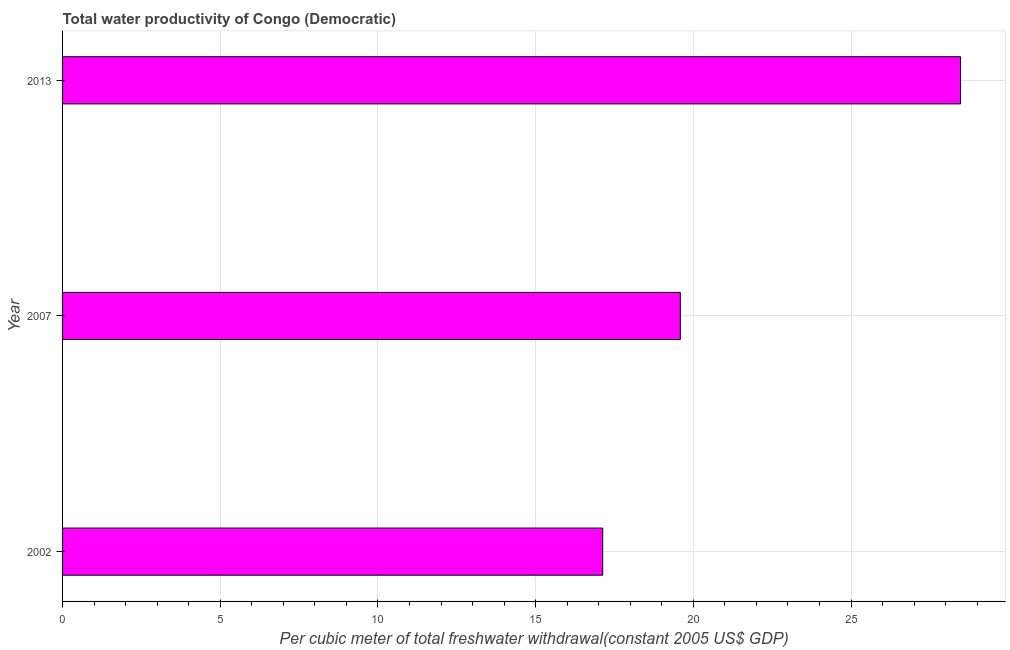Does the graph contain any zero values?
Provide a short and direct response. No. Does the graph contain grids?
Provide a succinct answer. Yes. What is the title of the graph?
Make the answer very short. Total water productivity of Congo (Democratic). What is the label or title of the X-axis?
Make the answer very short. Per cubic meter of total freshwater withdrawal(constant 2005 US$ GDP). What is the total water productivity in 2007?
Provide a succinct answer. 19.59. Across all years, what is the maximum total water productivity?
Keep it short and to the point. 28.47. Across all years, what is the minimum total water productivity?
Your response must be concise. 17.13. What is the sum of the total water productivity?
Keep it short and to the point. 65.19. What is the difference between the total water productivity in 2002 and 2013?
Offer a very short reply. -11.35. What is the average total water productivity per year?
Provide a succinct answer. 21.73. What is the median total water productivity?
Provide a succinct answer. 19.59. In how many years, is the total water productivity greater than 13 US$?
Give a very brief answer. 3. What is the ratio of the total water productivity in 2002 to that in 2013?
Give a very brief answer. 0.6. Is the difference between the total water productivity in 2002 and 2007 greater than the difference between any two years?
Keep it short and to the point. No. What is the difference between the highest and the second highest total water productivity?
Provide a short and direct response. 8.89. What is the difference between the highest and the lowest total water productivity?
Keep it short and to the point. 11.35. How many years are there in the graph?
Your answer should be very brief. 3. What is the difference between two consecutive major ticks on the X-axis?
Offer a very short reply. 5. Are the values on the major ticks of X-axis written in scientific E-notation?
Your answer should be very brief. No. What is the Per cubic meter of total freshwater withdrawal(constant 2005 US$ GDP) in 2002?
Provide a succinct answer. 17.13. What is the Per cubic meter of total freshwater withdrawal(constant 2005 US$ GDP) in 2007?
Keep it short and to the point. 19.59. What is the Per cubic meter of total freshwater withdrawal(constant 2005 US$ GDP) of 2013?
Provide a short and direct response. 28.47. What is the difference between the Per cubic meter of total freshwater withdrawal(constant 2005 US$ GDP) in 2002 and 2007?
Offer a very short reply. -2.46. What is the difference between the Per cubic meter of total freshwater withdrawal(constant 2005 US$ GDP) in 2002 and 2013?
Make the answer very short. -11.35. What is the difference between the Per cubic meter of total freshwater withdrawal(constant 2005 US$ GDP) in 2007 and 2013?
Your answer should be very brief. -8.89. What is the ratio of the Per cubic meter of total freshwater withdrawal(constant 2005 US$ GDP) in 2002 to that in 2007?
Your answer should be compact. 0.87. What is the ratio of the Per cubic meter of total freshwater withdrawal(constant 2005 US$ GDP) in 2002 to that in 2013?
Keep it short and to the point. 0.6. What is the ratio of the Per cubic meter of total freshwater withdrawal(constant 2005 US$ GDP) in 2007 to that in 2013?
Keep it short and to the point. 0.69. 